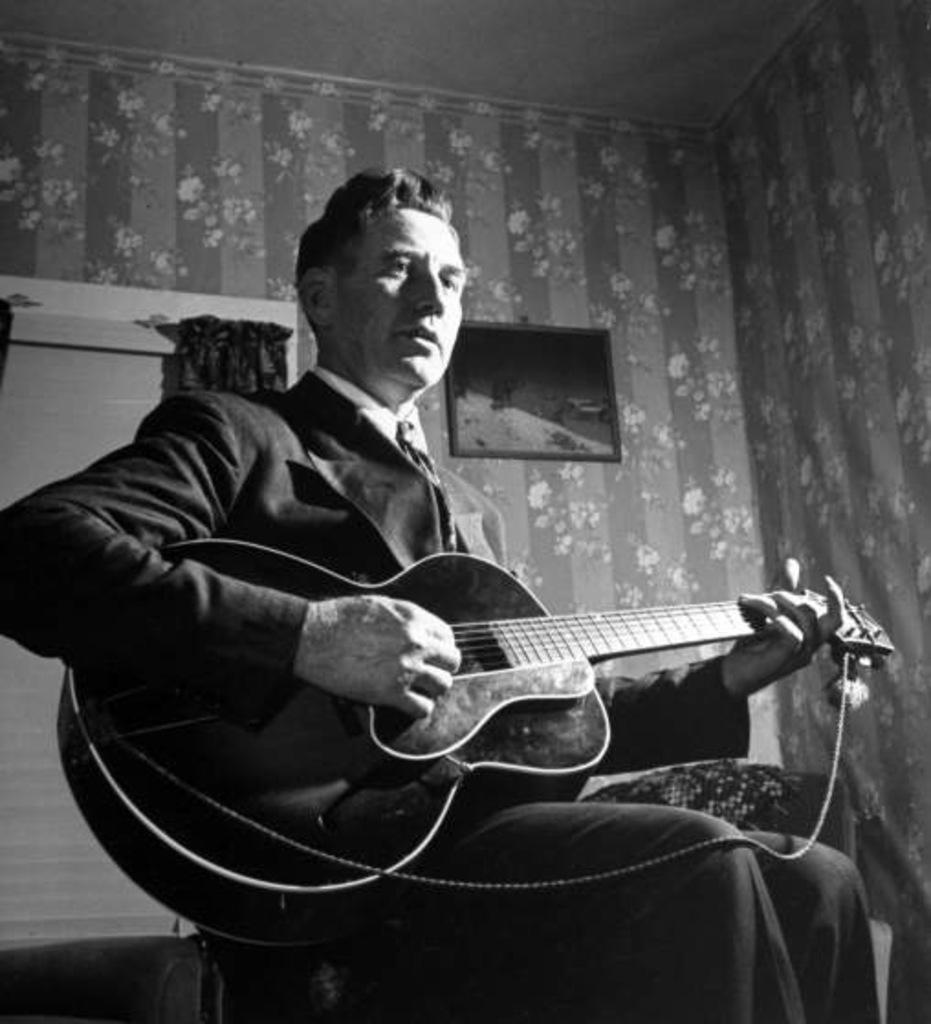What is the man in the image doing? The man is playing a guitar in the image. What can be seen behind the man? There is a wall behind the man. Is there anything attached to the wall? Yes, there is a photo frame attached to the wall. What type of beam is holding up the ceiling in the image? There is no mention of a ceiling or any beams in the image; it only shows a man playing a guitar with a wall and a photo frame in the background. 